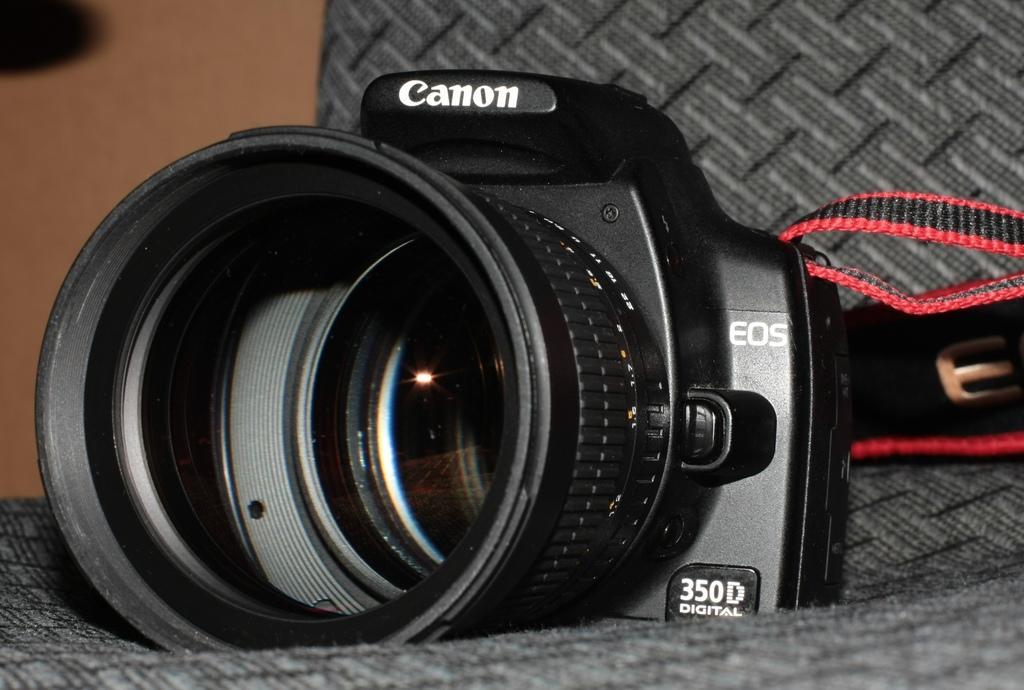How would you summarize this image in a sentence or two? Here there is black color camera. 